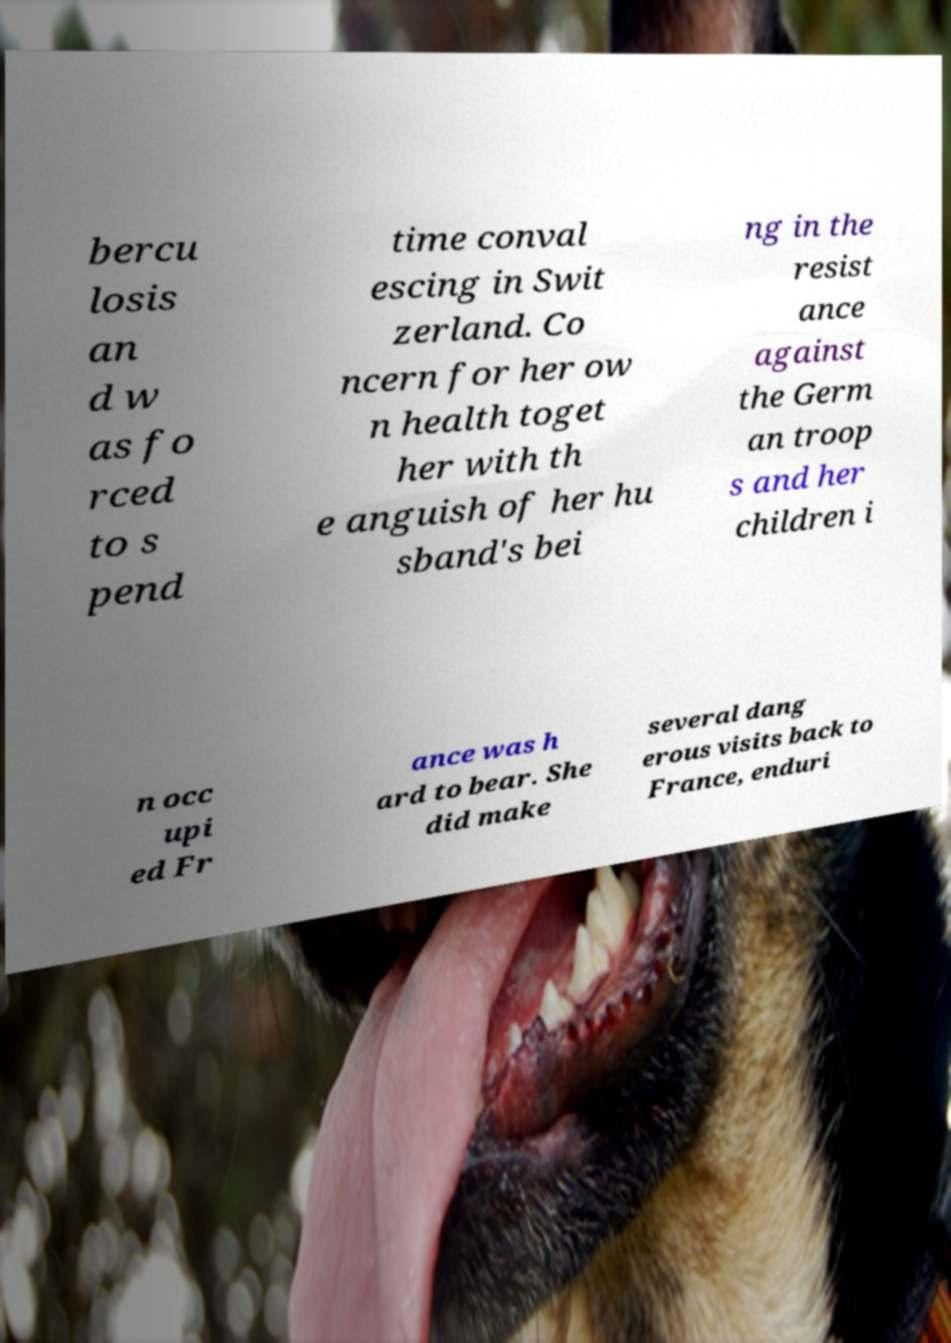Could you extract and type out the text from this image? bercu losis an d w as fo rced to s pend time conval escing in Swit zerland. Co ncern for her ow n health toget her with th e anguish of her hu sband's bei ng in the resist ance against the Germ an troop s and her children i n occ upi ed Fr ance was h ard to bear. She did make several dang erous visits back to France, enduri 